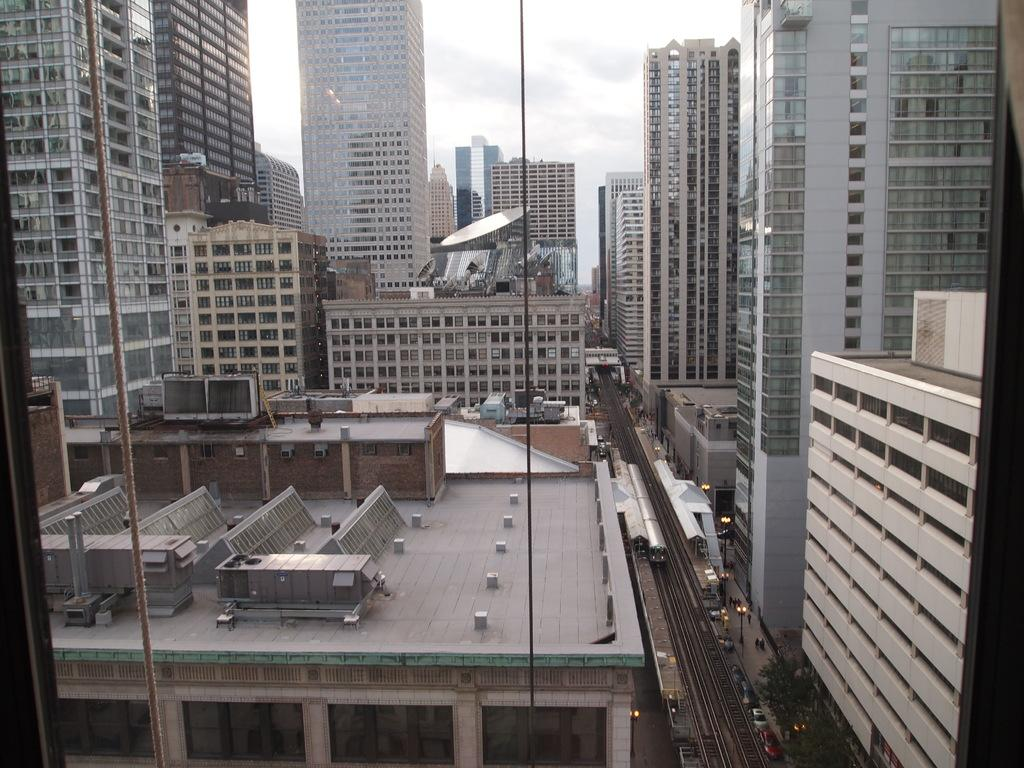What type of structures can be seen in the image? There are buildings in the image. What feature do the buildings have? The buildings have windows. What part of the natural environment is visible in the image? The sky is visible in the image. What type of brain can be seen in the image? There is no brain present in the image; it features buildings with windows and a visible sky. How does the house in the image behave? There is no house present in the image, only buildings with windows and a visible sky. 